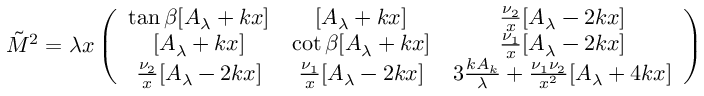Convert formula to latex. <formula><loc_0><loc_0><loc_500><loc_500>\tilde { M } ^ { 2 } = \lambda x \left ( \begin{array} { c c c } { { \tan \beta [ A _ { \lambda } + k x ] } } & { { [ A _ { \lambda } + k x ] } } & { { \frac { \nu _ { 2 } } { x } [ A _ { \lambda } - 2 k x ] } } \\ { { [ A _ { \lambda } + k x ] } } & { { \cot \beta [ A _ { \lambda } + k x ] } } & { { \frac { \nu _ { 1 } } { x } [ A _ { \lambda } - 2 k x ] } } \\ { { \frac { \nu _ { 2 } } { x } [ A _ { \lambda } - 2 k x ] } } & { { \frac { \nu _ { 1 } } { x } [ A _ { \lambda } - 2 k x ] } } & { { 3 \frac { k A _ { k } } { \lambda } + \frac { \nu _ { 1 } \nu _ { 2 } } { x ^ { 2 } } [ A _ { \lambda } + 4 k x ] } } \end{array} \right )</formula> 